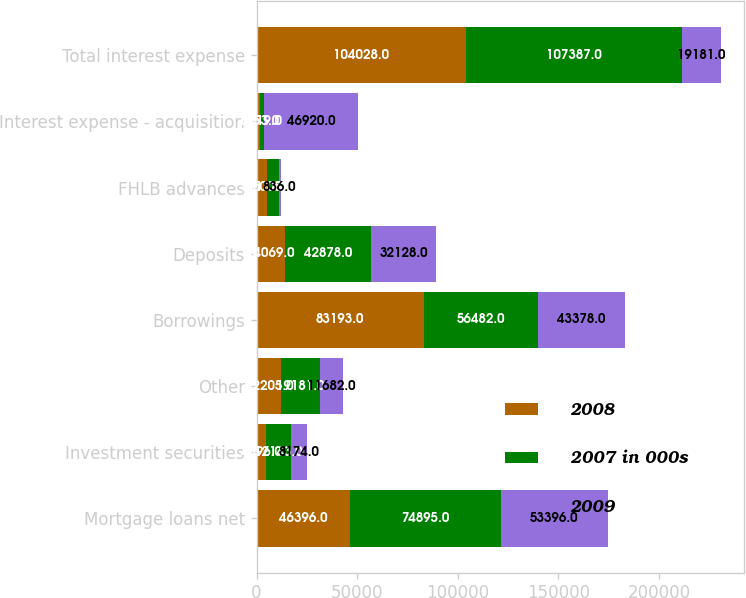Convert chart to OTSL. <chart><loc_0><loc_0><loc_500><loc_500><stacked_bar_chart><ecel><fcel>Mortgage loans net<fcel>Investment securities<fcel>Other<fcel>Borrowings<fcel>Deposits<fcel>FHLB advances<fcel>Interest expense - acquisition<fcel>Total interest expense<nl><fcel>2008<fcel>46396<fcel>4896<fcel>12205<fcel>83193<fcel>14069<fcel>5113<fcel>1653<fcel>104028<nl><fcel>2007 in 000s<fcel>74895<fcel>12143<fcel>19181<fcel>56482<fcel>42878<fcel>6008<fcel>2019<fcel>107387<nl><fcel>2009<fcel>53396<fcel>8174<fcel>11682<fcel>43378<fcel>32128<fcel>836<fcel>46920<fcel>19181<nl></chart> 